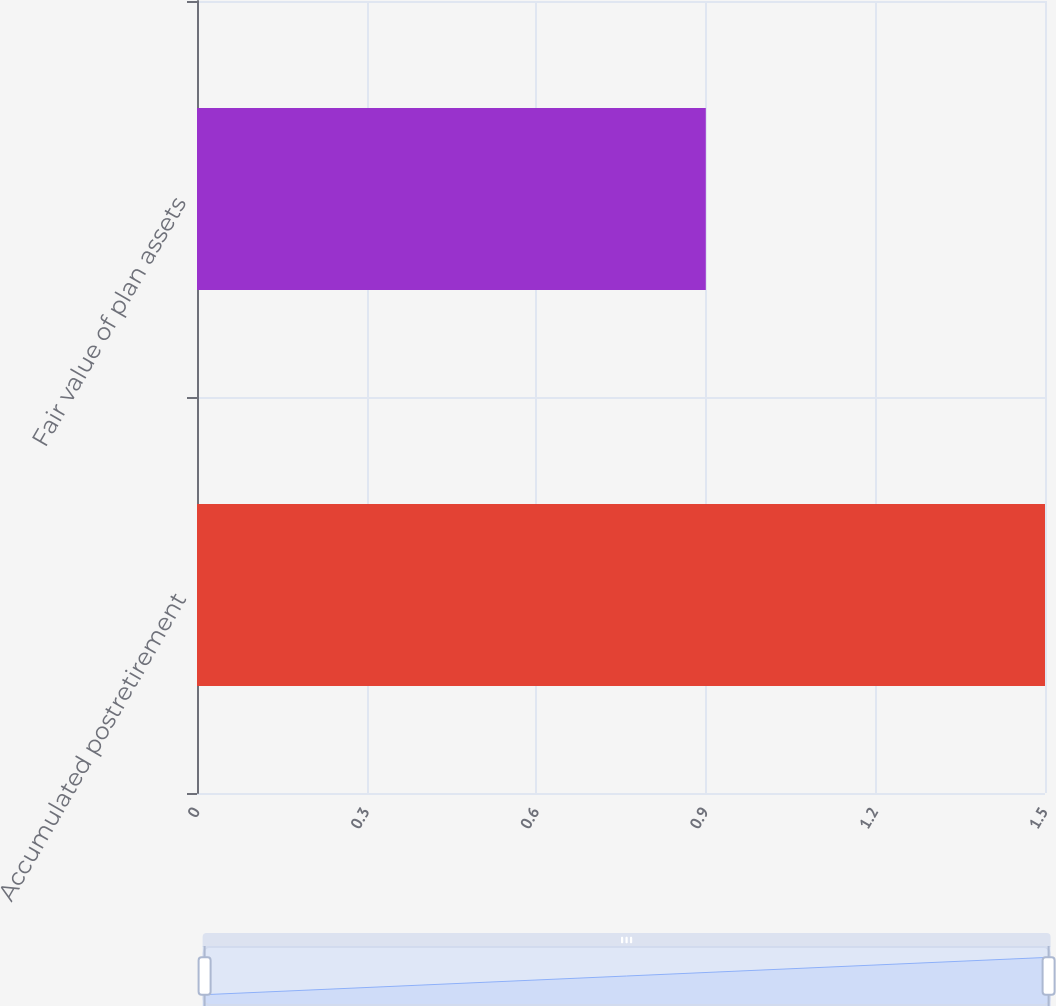Convert chart to OTSL. <chart><loc_0><loc_0><loc_500><loc_500><bar_chart><fcel>Accumulated postretirement<fcel>Fair value of plan assets<nl><fcel>1.5<fcel>0.9<nl></chart> 